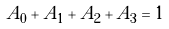Convert formula to latex. <formula><loc_0><loc_0><loc_500><loc_500>A _ { 0 } + A _ { 1 } + A _ { 2 } + A _ { 3 } = 1</formula> 